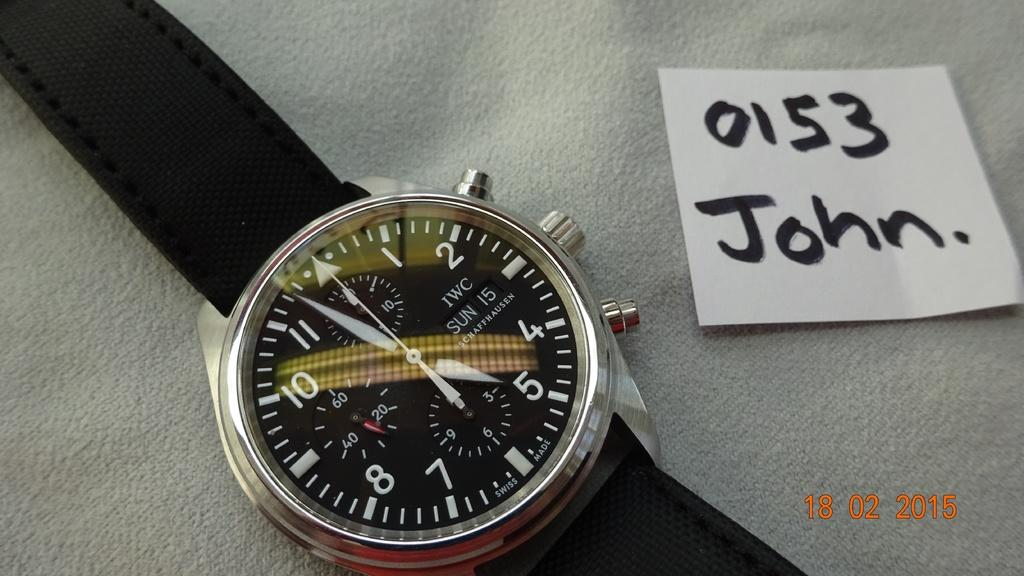<image>
Give a short and clear explanation of the subsequent image. The date stamp on the photo is 18/02/2015 